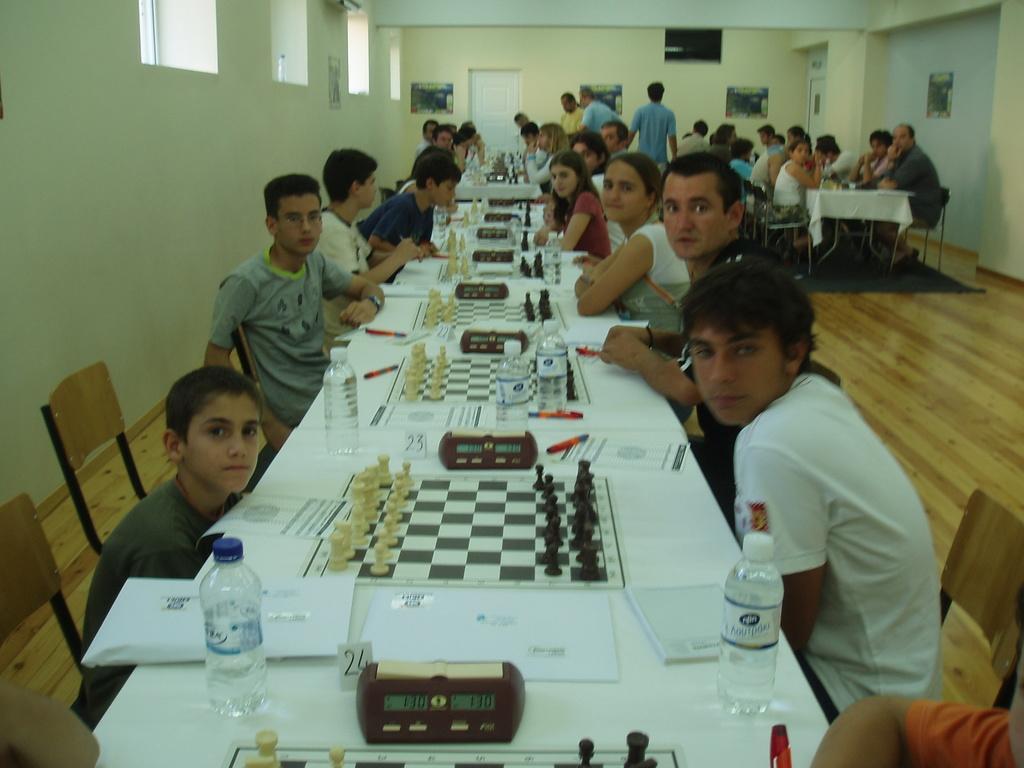Could you give a brief overview of what you see in this image? There is a group of people. They are sitting on a chairs. There is a table. There is a laptop,bottle,pen,sketch on a table. We can see in background wall and door. 